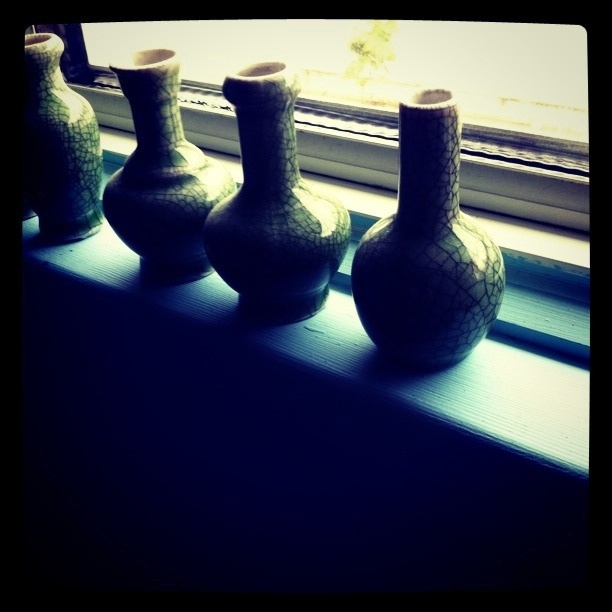Describe the objects in this image and their specific colors. I can see vase in black, navy, gray, and lightyellow tones, vase in black, navy, lightyellow, and gray tones, vase in black, navy, lightyellow, and khaki tones, and vase in black, navy, khaki, and gray tones in this image. 